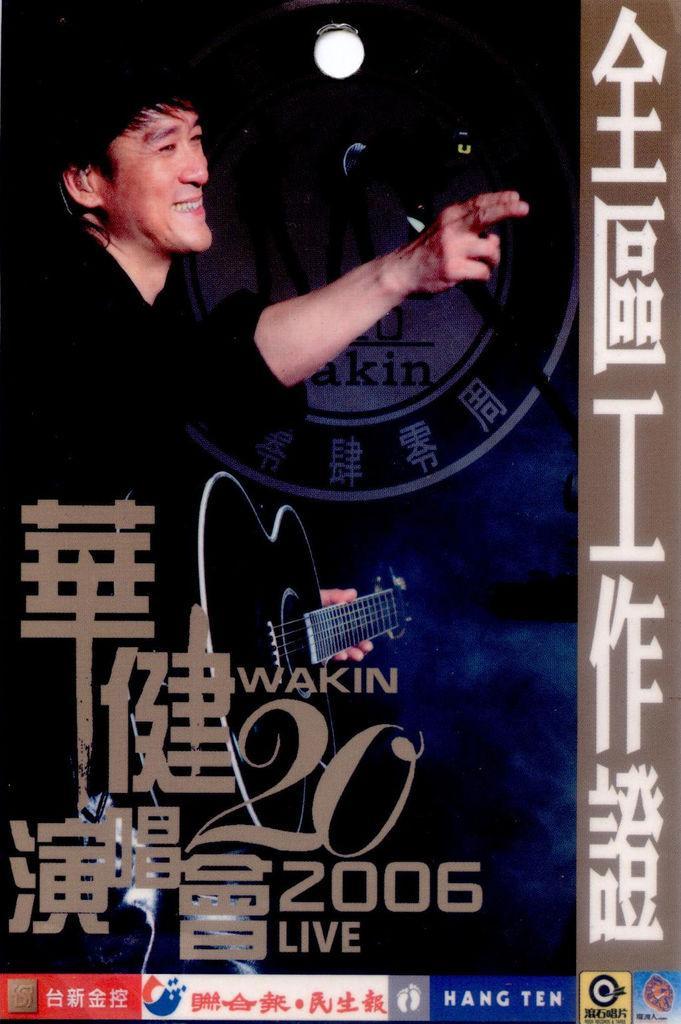Describe this image in one or two sentences. This image is an advertisement. In this image we can see text and person holding guitar. 